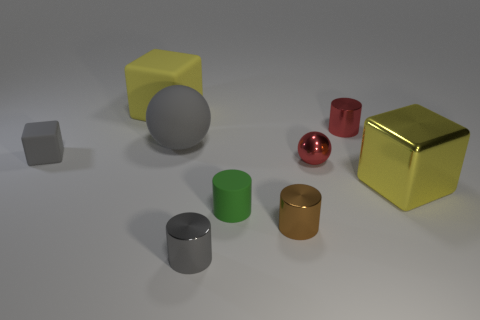Subtract all green spheres. Subtract all red blocks. How many spheres are left? 2 Add 1 cyan objects. How many objects exist? 10 Subtract all cylinders. How many objects are left? 5 Subtract 1 gray blocks. How many objects are left? 8 Subtract all big shiny spheres. Subtract all tiny red metal objects. How many objects are left? 7 Add 5 tiny matte cylinders. How many tiny matte cylinders are left? 6 Add 5 small green rubber cylinders. How many small green rubber cylinders exist? 6 